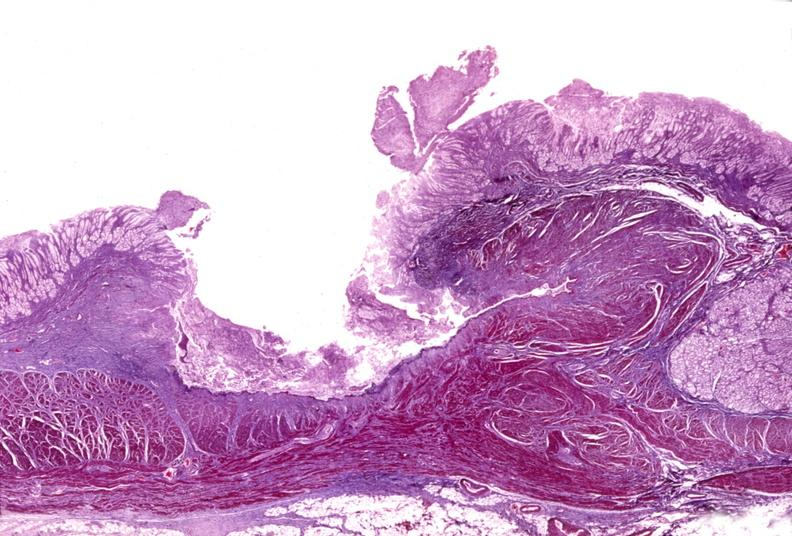does this image show stomach, subacute peptic ulcer?
Answer the question using a single word or phrase. Yes 